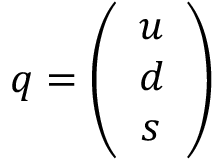Convert formula to latex. <formula><loc_0><loc_0><loc_500><loc_500>q = \left ( \begin{array} { c } { u } \\ { d } \\ { s } \end{array} \right )</formula> 